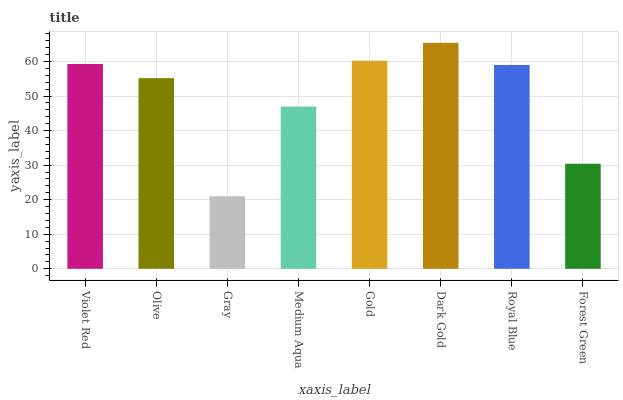Is Gray the minimum?
Answer yes or no. Yes. Is Dark Gold the maximum?
Answer yes or no. Yes. Is Olive the minimum?
Answer yes or no. No. Is Olive the maximum?
Answer yes or no. No. Is Violet Red greater than Olive?
Answer yes or no. Yes. Is Olive less than Violet Red?
Answer yes or no. Yes. Is Olive greater than Violet Red?
Answer yes or no. No. Is Violet Red less than Olive?
Answer yes or no. No. Is Royal Blue the high median?
Answer yes or no. Yes. Is Olive the low median?
Answer yes or no. Yes. Is Violet Red the high median?
Answer yes or no. No. Is Gold the low median?
Answer yes or no. No. 